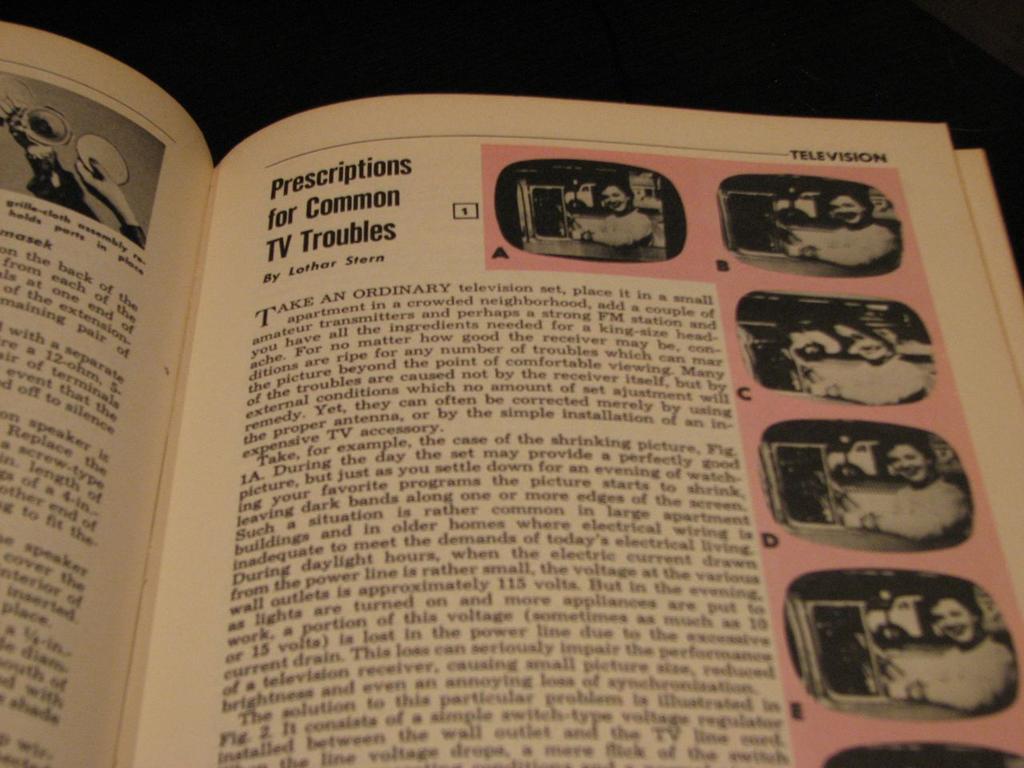What is the name of the article?
Offer a very short reply. Prescriptions for common tv troubles. 